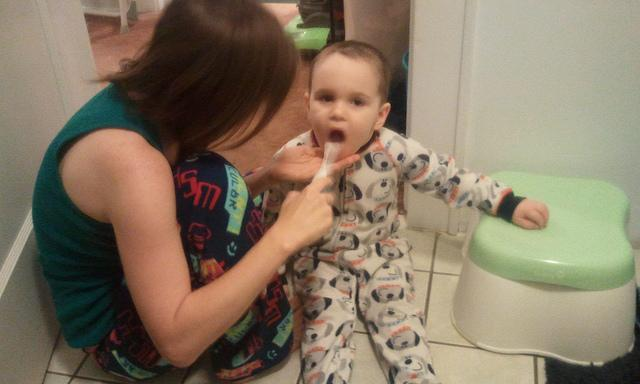What is the woman helping the child do? Please explain your reasoning. brush teeth. The kid is brushing their teeth. 